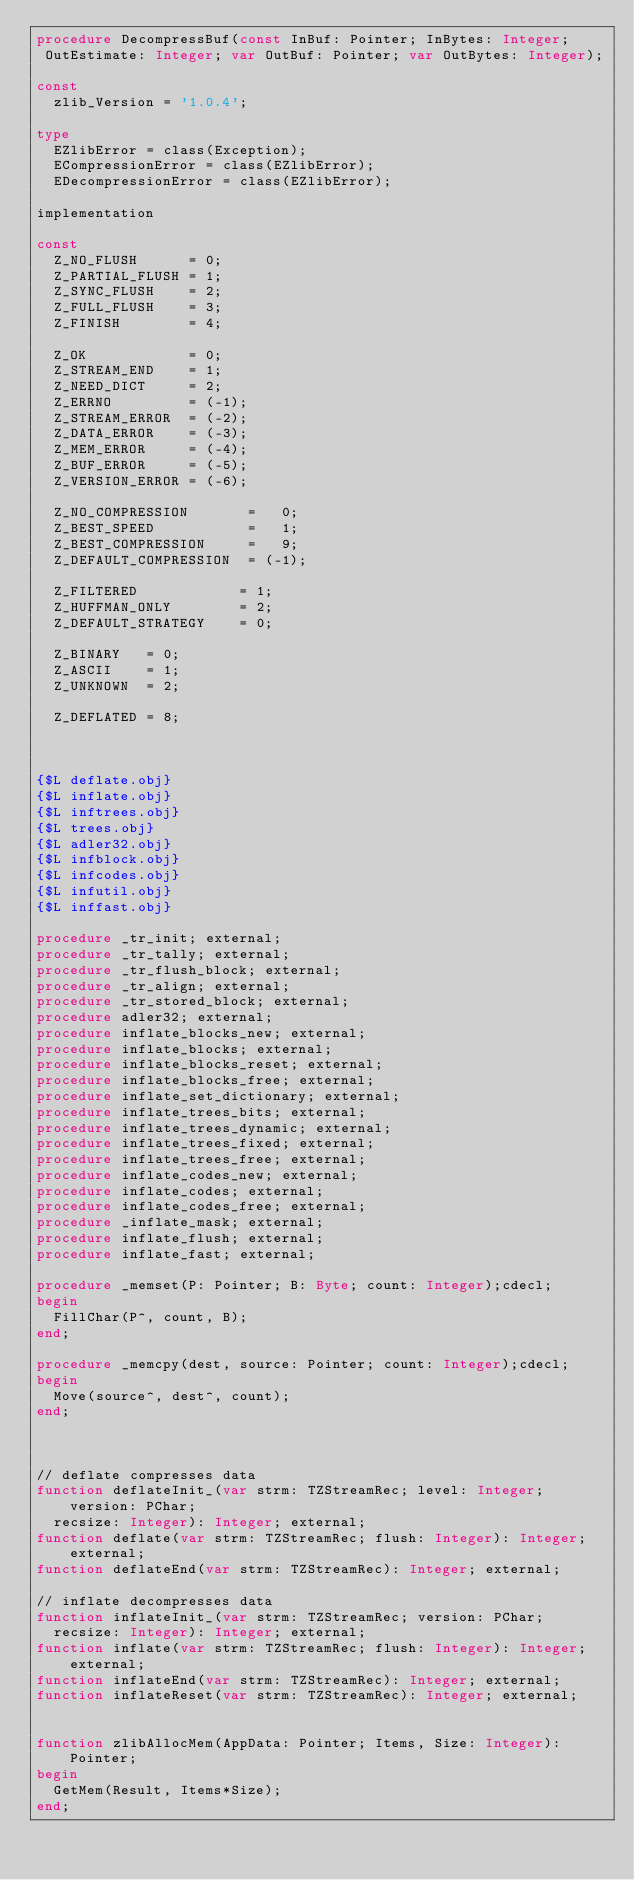Convert code to text. <code><loc_0><loc_0><loc_500><loc_500><_Pascal_>procedure DecompressBuf(const InBuf: Pointer; InBytes: Integer;
 OutEstimate: Integer; var OutBuf: Pointer; var OutBytes: Integer);

const
  zlib_Version = '1.0.4';

type
  EZlibError = class(Exception);
  ECompressionError = class(EZlibError);
  EDecompressionError = class(EZlibError);

implementation

const
  Z_NO_FLUSH      = 0;
  Z_PARTIAL_FLUSH = 1;
  Z_SYNC_FLUSH    = 2;
  Z_FULL_FLUSH    = 3;
  Z_FINISH        = 4;

  Z_OK            = 0;
  Z_STREAM_END    = 1;
  Z_NEED_DICT     = 2;
  Z_ERRNO         = (-1);
  Z_STREAM_ERROR  = (-2);
  Z_DATA_ERROR    = (-3);
  Z_MEM_ERROR     = (-4);
  Z_BUF_ERROR     = (-5);
  Z_VERSION_ERROR = (-6);

  Z_NO_COMPRESSION       =   0;
  Z_BEST_SPEED           =   1;
  Z_BEST_COMPRESSION     =   9;
  Z_DEFAULT_COMPRESSION  = (-1);

  Z_FILTERED            = 1;
  Z_HUFFMAN_ONLY        = 2;
  Z_DEFAULT_STRATEGY    = 0;

  Z_BINARY   = 0;
  Z_ASCII    = 1;
  Z_UNKNOWN  = 2;

  Z_DEFLATED = 8;



{$L deflate.obj}
{$L inflate.obj}
{$L inftrees.obj}
{$L trees.obj}
{$L adler32.obj}
{$L infblock.obj}
{$L infcodes.obj}
{$L infutil.obj}
{$L inffast.obj}

procedure _tr_init; external;
procedure _tr_tally; external;
procedure _tr_flush_block; external;
procedure _tr_align; external;
procedure _tr_stored_block; external;
procedure adler32; external;
procedure inflate_blocks_new; external;
procedure inflate_blocks; external;
procedure inflate_blocks_reset; external;
procedure inflate_blocks_free; external;
procedure inflate_set_dictionary; external;
procedure inflate_trees_bits; external;
procedure inflate_trees_dynamic; external;
procedure inflate_trees_fixed; external;
procedure inflate_trees_free; external;
procedure inflate_codes_new; external;
procedure inflate_codes; external;
procedure inflate_codes_free; external;
procedure _inflate_mask; external;
procedure inflate_flush; external;
procedure inflate_fast; external;

procedure _memset(P: Pointer; B: Byte; count: Integer);cdecl;
begin
  FillChar(P^, count, B);
end;

procedure _memcpy(dest, source: Pointer; count: Integer);cdecl;
begin
  Move(source^, dest^, count);
end;



// deflate compresses data
function deflateInit_(var strm: TZStreamRec; level: Integer; version: PChar;
  recsize: Integer): Integer; external;
function deflate(var strm: TZStreamRec; flush: Integer): Integer; external;
function deflateEnd(var strm: TZStreamRec): Integer; external;

// inflate decompresses data
function inflateInit_(var strm: TZStreamRec; version: PChar;
  recsize: Integer): Integer; external;
function inflate(var strm: TZStreamRec; flush: Integer): Integer; external;
function inflateEnd(var strm: TZStreamRec): Integer; external;
function inflateReset(var strm: TZStreamRec): Integer; external;


function zlibAllocMem(AppData: Pointer; Items, Size: Integer): Pointer;
begin
  GetMem(Result, Items*Size);
end;
</code> 